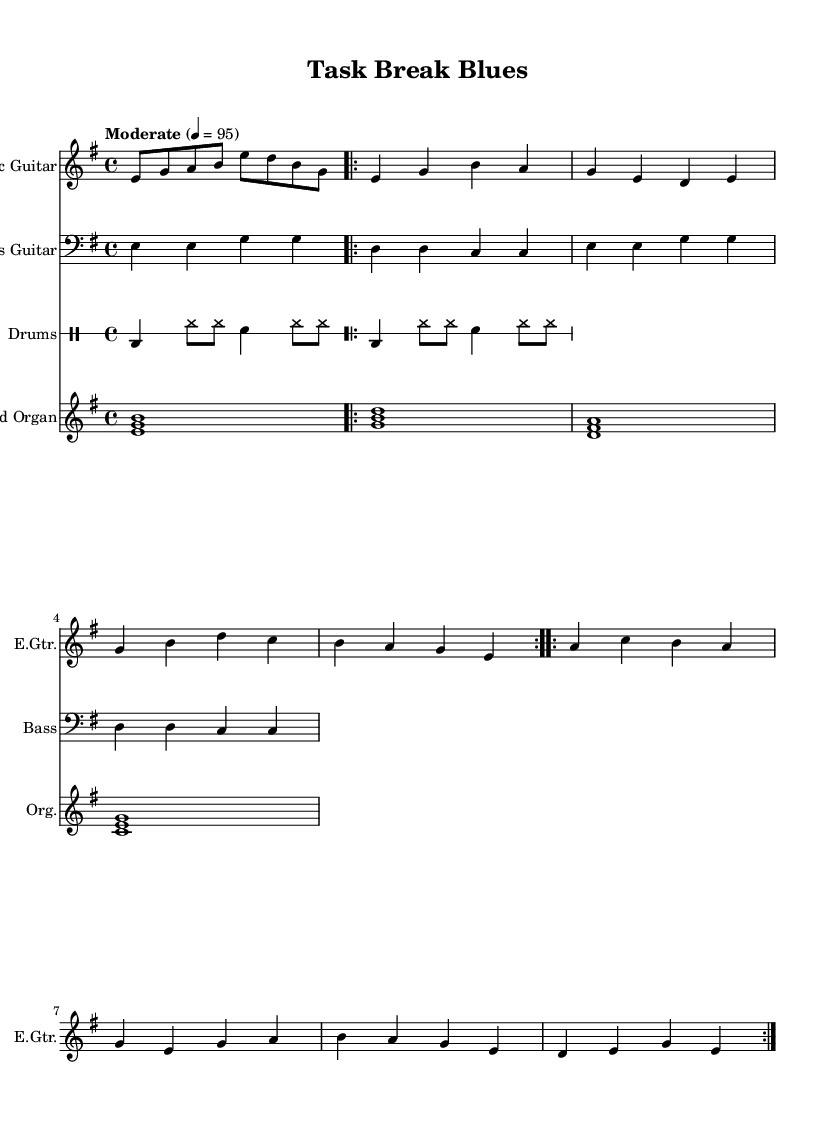What is the key signature of this music? The key signature is E minor, indicated by one sharp (F#) to the left of the staff. E minor is defined by its relative major, G major, which shares the same key signature.
Answer: E minor What is the time signature of this music? The time signature is 4/4, as indicated at the beginning of the score. This means there are four beats in each measure, and the quarter note receives one beat.
Answer: 4/4 What is the tempo marking? The tempo marking is "Moderate," with a metronome indication of 95 beats per minute, suggesting a relaxed speed suitable for blues music.
Answer: Moderate How many measures are in the intro? The intro consists of one measure as indicated by the music notation before the verse begins.
Answer: 1 Which instrument plays the sustained chords? The Hammond Organ plays the sustained chords, as indicated in its respective staff notation. These chords are played throughout the composition, providing harmonic support.
Answer: Hammond Organ How does the verse melody differ from the chorus melody? The verse melody features different note patterns and rhythms compared to the chorus, which has a more repetitive and anthemic structure, typical of blues music. The verse uses a sequence of eighth and quarter notes, while the chorus emphasizes longer notes.
Answer: Different patterns What typical elements of Electric Blues are present in this piece? The piece contains a gritty guitar riff, a steady rock beat on drums, a bluesy bass line, and soulful organ chords, all essential characteristics of Electric Blues.
Answer: Gritty guitar, steady rock beat, bluesy bass, soulful organ 